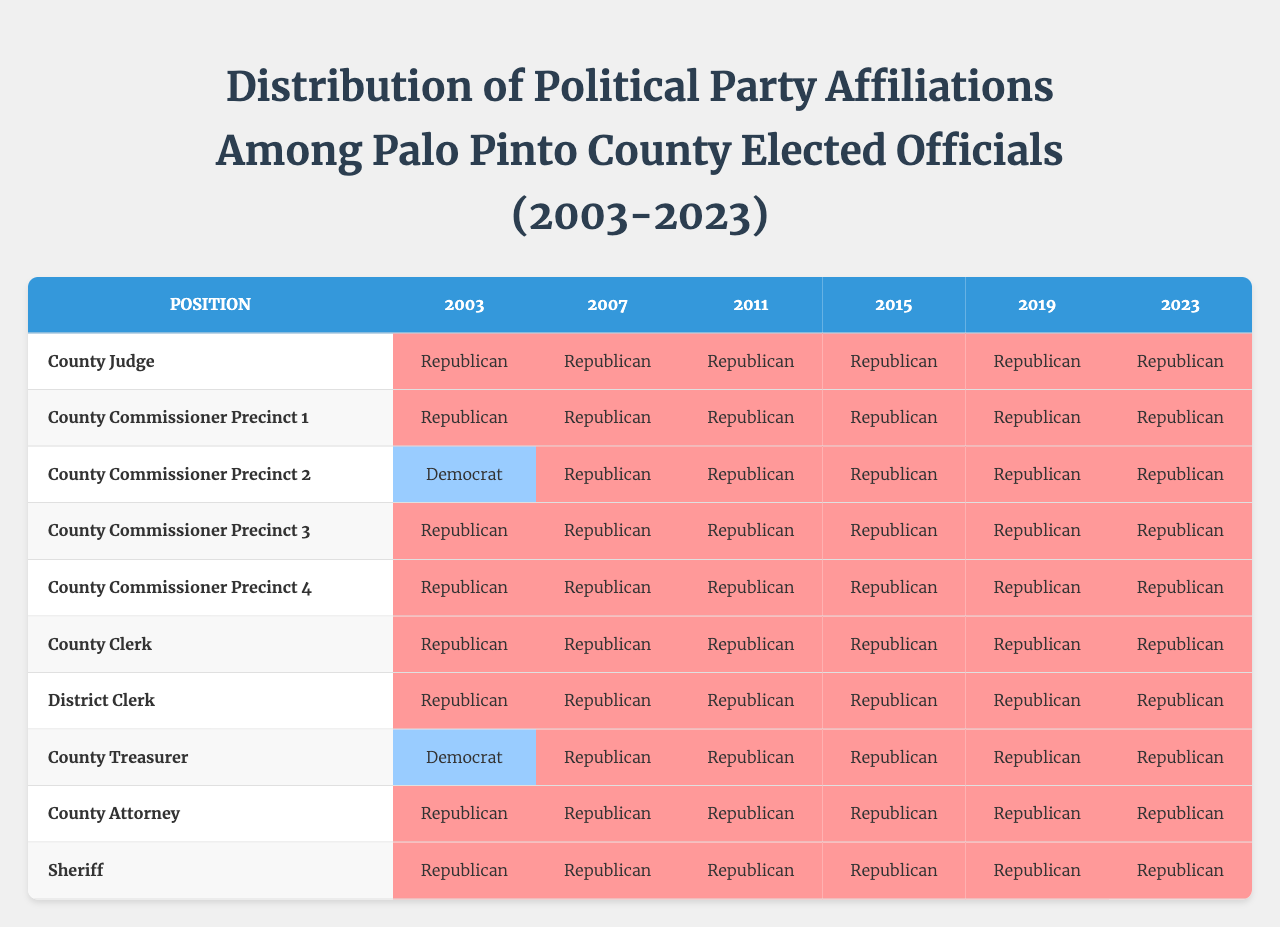What political party did the County Judge belong to in 2023? The table indicates that in 2023, the County Judge's affiliation was "Republican."
Answer: Republican Which political position had a Democrat affiliation in 2003? Referring to the 2003 data, the County Commissioner Precinct 2 had a "Democrat" affiliation.
Answer: County Commissioner Precinct 2 How many positions were held by Republicans in 2019? In 2019, all positions listed in the table were held by Republicans, totaling 10 positions.
Answer: 10 Is there any year in which the County Clerk was not a Republican? The table shows that in every year from 2003 to 2023, the County Clerk was a "Republican." Therefore, the answer is "no."
Answer: No What is the difference in party affiliations for County Treasurer from 2003 to 2023? In 2003, the County Treasurer was affiliated with the "Democrat" party, while in 2023, the County Treasurer is affiliated with the "Republican" party, indicating a shift in party by one affiliation towards the Republican side.
Answer: Shift from Democrat to Republican How many years had the County Attorney been a Republican by 2023? The County Attorney has been a "Republican" from 2003 to 2023. Counting these years gives us 6 years where this position was held by a Republican.
Answer: 6 years In which year did the majority of County Commissioner Precincts hold a Democratic affiliation? The table shows that in 2003, only one County Commissioner Precinct was held by a Democrat, while all others were Republican in each subsequent year. Thus, 2003 is the only year with a Democratic representative.
Answer: 2003 Is it true that the Sheriff position has been held by a Republican for all years in this table? Looking at the data for all years from 2003 to 2023, the Sheriff position is marked as "Republican" in every instance, confirming the statement as true.
Answer: Yes What is the trend of political party affiliations in Palo Pinto County over the 20 years according to this data? The table indicates a clear trend towards Republican dominance, with only a few Democratic positions in 2003, all moving to Republican in subsequent years.
Answer: Shift towards Republican dominance What percentage of the total positions were held by Democrats in 2003? In 2003, there were 2 positions (County Commissioner Precinct 2 and County Treasurer) affiliated with the Democratic party out of a total of 10 positions, resulting in a percentage calculation of (2/10) * 100 = 20%.
Answer: 20% 